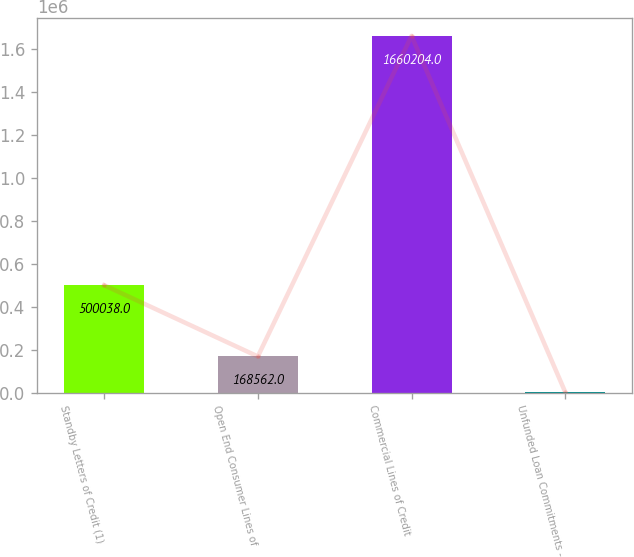Convert chart to OTSL. <chart><loc_0><loc_0><loc_500><loc_500><bar_chart><fcel>Standby Letters of Credit (1)<fcel>Open End Consumer Lines of<fcel>Commercial Lines of Credit<fcel>Unfunded Loan Commitments -<nl><fcel>500038<fcel>168562<fcel>1.6602e+06<fcel>2824<nl></chart> 